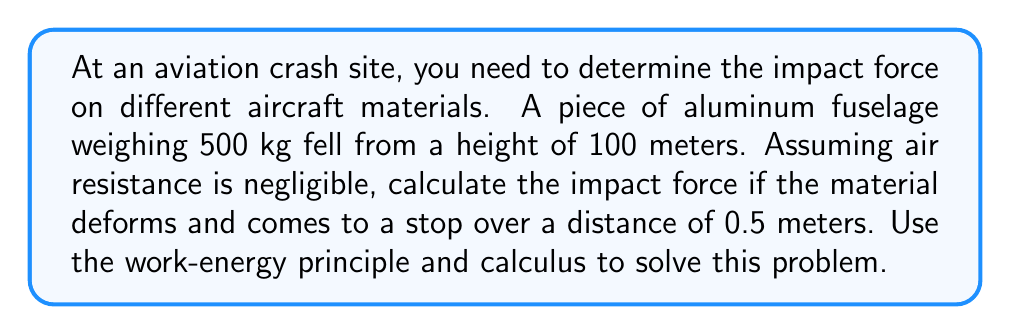Can you answer this question? To solve this problem, we'll use the work-energy principle and calculus. Let's break it down step-by-step:

1) First, we need to calculate the velocity of the object just before impact. We can use the equation for potential energy:

   $PE = mgh$

   where $m$ is mass, $g$ is acceleration due to gravity, and $h$ is height.

   This potential energy is converted to kinetic energy at impact:

   $KE = \frac{1}{2}mv^2$

   Setting these equal:

   $mgh = \frac{1}{2}mv^2$

2) Solving for $v$:

   $v = \sqrt{2gh} = \sqrt{2 \cdot 9.8 \cdot 100} \approx 44.27$ m/s

3) Now, we know the initial velocity at impact. We need to find the force that brings the object to rest over a distance of 0.5 meters. We can use the work-energy theorem:

   $W = \Delta KE$

   Where work $W = \int F(x) dx$, and $\Delta KE$ is the change in kinetic energy.

4) The change in kinetic energy is:

   $\Delta KE = KE_{final} - KE_{initial} = 0 - \frac{1}{2}mv^2 = -\frac{1}{2}mv^2$

5) Now we can set up our equation:

   $\int_0^{0.5} F(x) dx = -\frac{1}{2}mv^2$

6) We don't know the exact function for $F(x)$, but we can assume it's approximately constant over this small distance. Let's call this constant force $F$. Then:

   $F \cdot 0.5 = -\frac{1}{2}mv^2$

7) Solving for $F$:

   $F = -\frac{mv^2}{1}$

8) Now we can plug in our values:

   $F = -\frac{500 \cdot (44.27)^2}{1} \approx -979,897$ N

The negative sign indicates the force is in the opposite direction of the motion.
Answer: The impact force on the aluminum fuselage is approximately 979,897 N or 980 kN. 